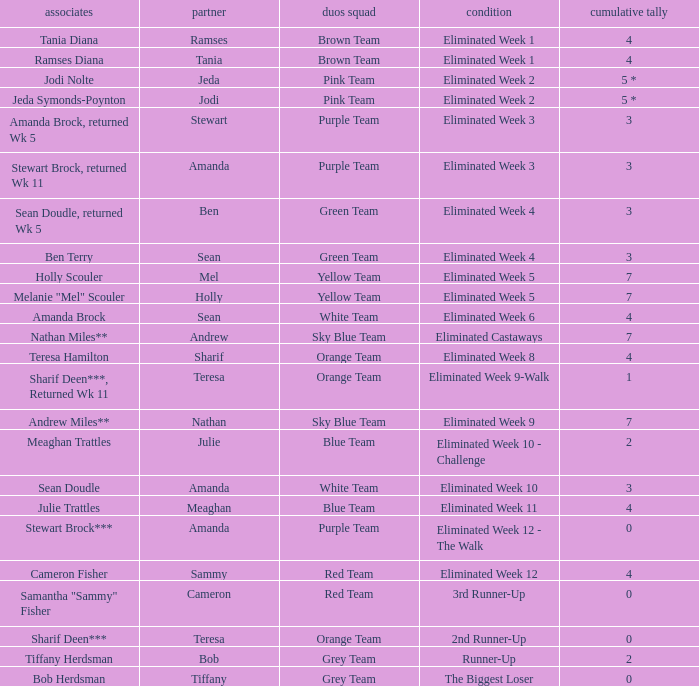Who had 0 total votes in the purple team? Eliminated Week 12 - The Walk. 